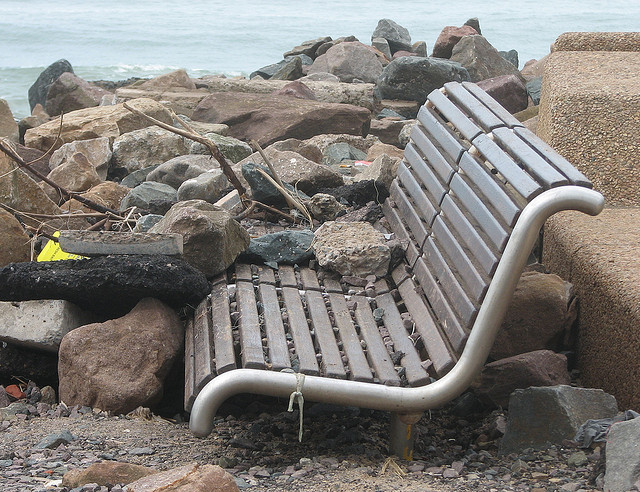How many benches are in the picture? 1 